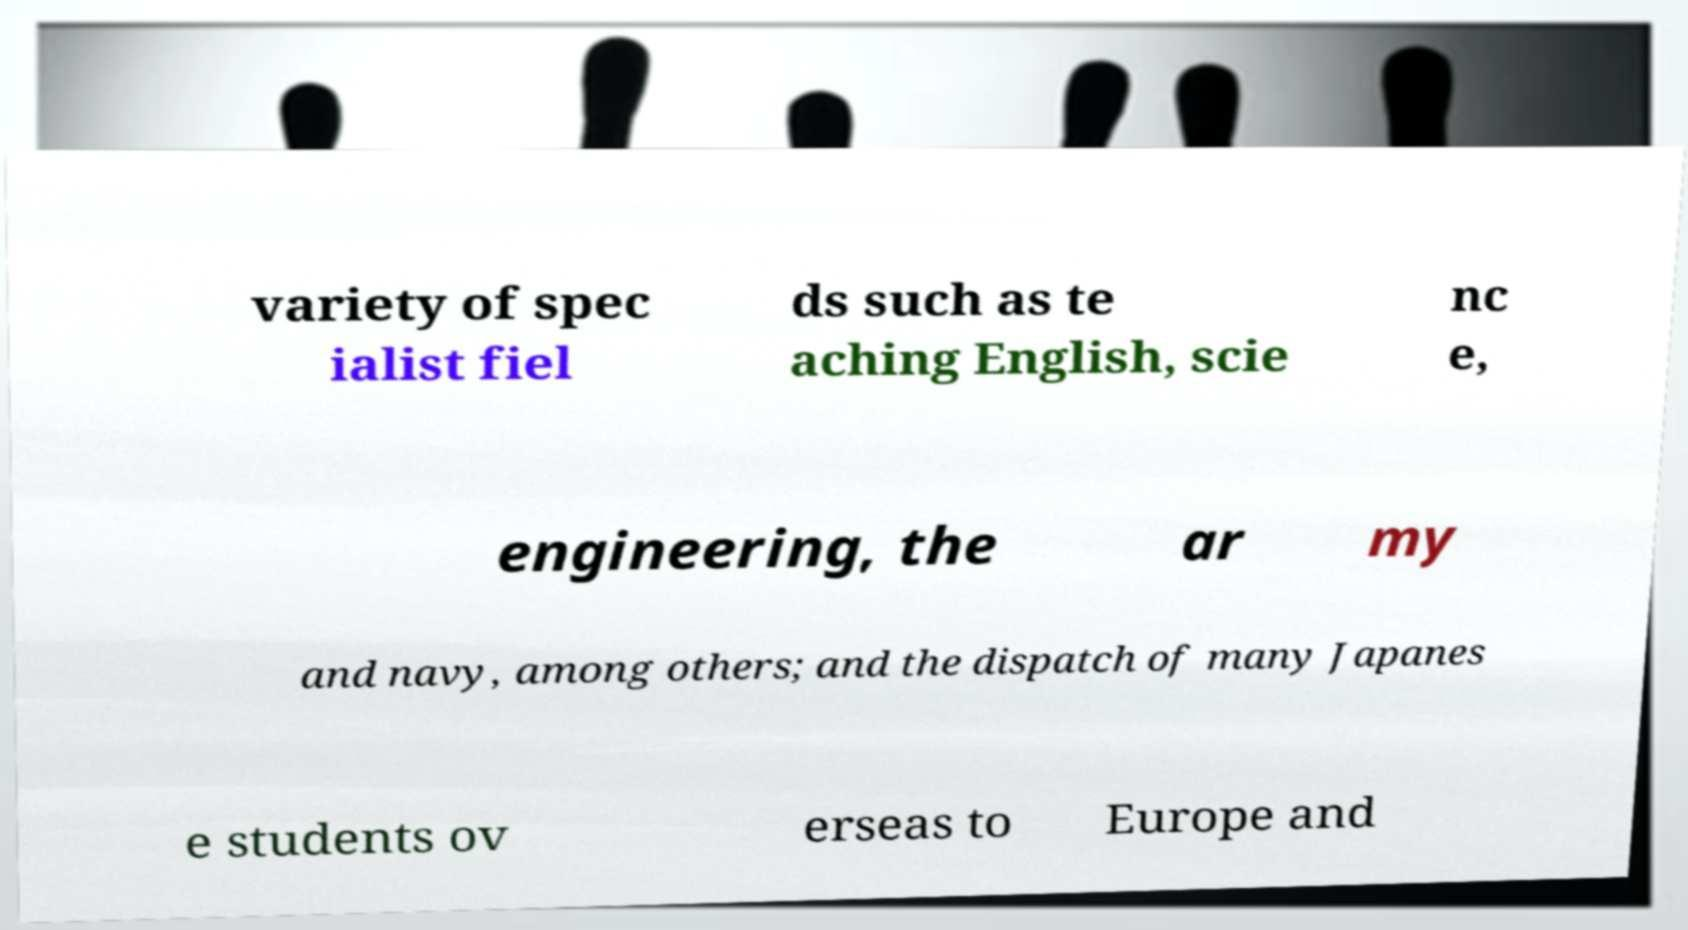What messages or text are displayed in this image? I need them in a readable, typed format. variety of spec ialist fiel ds such as te aching English, scie nc e, engineering, the ar my and navy, among others; and the dispatch of many Japanes e students ov erseas to Europe and 